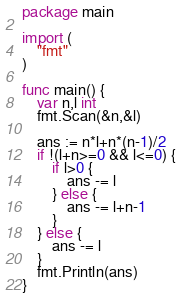Convert code to text. <code><loc_0><loc_0><loc_500><loc_500><_Go_>package main

import (
	"fmt"
)

func main() {
	var n,l int
	fmt.Scan(&n,&l)

	ans := n*l+n*(n-1)/2
	if !(l+n>=0 && l<=0) {
		if l>0 {
			ans -= l
		} else {
			ans -= l+n-1
		}
	} else {
		ans -= l
	}
	fmt.Println(ans)
}
</code> 